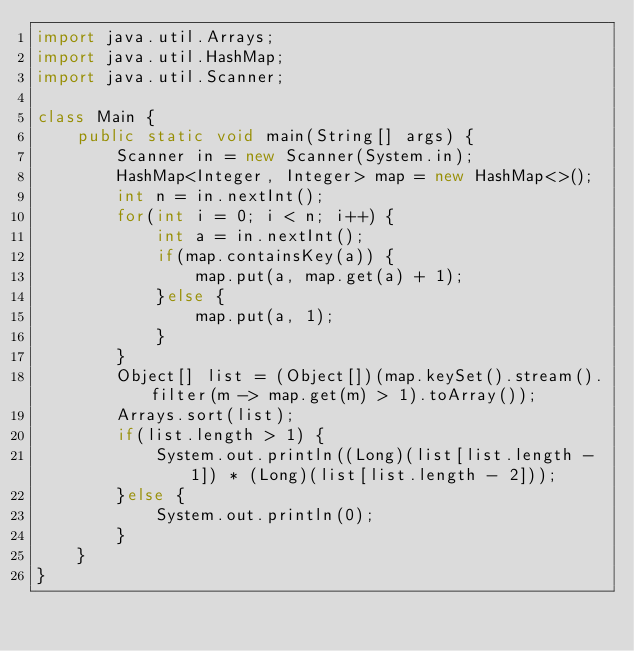<code> <loc_0><loc_0><loc_500><loc_500><_Java_>import java.util.Arrays;
import java.util.HashMap;
import java.util.Scanner;

class Main {
    public static void main(String[] args) {
        Scanner in = new Scanner(System.in);
        HashMap<Integer, Integer> map = new HashMap<>();
        int n = in.nextInt();
        for(int i = 0; i < n; i++) {
            int a = in.nextInt();
            if(map.containsKey(a)) {
                map.put(a, map.get(a) + 1);
            }else {
                map.put(a, 1);
            }
        }
        Object[] list = (Object[])(map.keySet().stream().filter(m -> map.get(m) > 1).toArray());
        Arrays.sort(list);
        if(list.length > 1) {
            System.out.println((Long)(list[list.length - 1]) * (Long)(list[list.length - 2]));
        }else {
            System.out.println(0);
        }
    }
}
</code> 